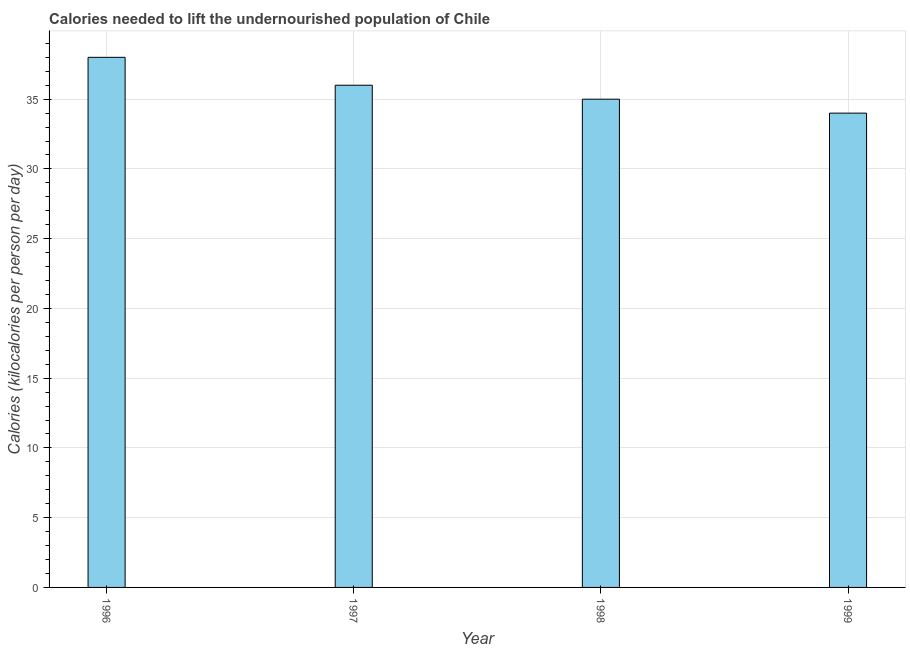Does the graph contain any zero values?
Your response must be concise. No. What is the title of the graph?
Provide a succinct answer. Calories needed to lift the undernourished population of Chile. What is the label or title of the X-axis?
Give a very brief answer. Year. What is the label or title of the Y-axis?
Give a very brief answer. Calories (kilocalories per person per day). Across all years, what is the maximum depth of food deficit?
Provide a succinct answer. 38. In which year was the depth of food deficit minimum?
Make the answer very short. 1999. What is the sum of the depth of food deficit?
Offer a terse response. 143. What is the median depth of food deficit?
Your answer should be compact. 35.5. Do a majority of the years between 1999 and 1997 (inclusive) have depth of food deficit greater than 23 kilocalories?
Provide a short and direct response. Yes. What is the ratio of the depth of food deficit in 1997 to that in 1999?
Keep it short and to the point. 1.06. What is the difference between the highest and the second highest depth of food deficit?
Make the answer very short. 2. What is the difference between the highest and the lowest depth of food deficit?
Your response must be concise. 4. In how many years, is the depth of food deficit greater than the average depth of food deficit taken over all years?
Your response must be concise. 2. Are all the bars in the graph horizontal?
Offer a very short reply. No. How many years are there in the graph?
Offer a terse response. 4. What is the difference between two consecutive major ticks on the Y-axis?
Make the answer very short. 5. What is the Calories (kilocalories per person per day) of 1999?
Keep it short and to the point. 34. What is the difference between the Calories (kilocalories per person per day) in 1996 and 1997?
Your answer should be very brief. 2. What is the difference between the Calories (kilocalories per person per day) in 1996 and 1998?
Your answer should be very brief. 3. What is the difference between the Calories (kilocalories per person per day) in 1996 and 1999?
Ensure brevity in your answer.  4. What is the difference between the Calories (kilocalories per person per day) in 1997 and 1998?
Give a very brief answer. 1. What is the difference between the Calories (kilocalories per person per day) in 1997 and 1999?
Provide a short and direct response. 2. What is the difference between the Calories (kilocalories per person per day) in 1998 and 1999?
Your answer should be very brief. 1. What is the ratio of the Calories (kilocalories per person per day) in 1996 to that in 1997?
Your response must be concise. 1.06. What is the ratio of the Calories (kilocalories per person per day) in 1996 to that in 1998?
Keep it short and to the point. 1.09. What is the ratio of the Calories (kilocalories per person per day) in 1996 to that in 1999?
Provide a succinct answer. 1.12. What is the ratio of the Calories (kilocalories per person per day) in 1997 to that in 1998?
Offer a terse response. 1.03. What is the ratio of the Calories (kilocalories per person per day) in 1997 to that in 1999?
Offer a terse response. 1.06. What is the ratio of the Calories (kilocalories per person per day) in 1998 to that in 1999?
Offer a very short reply. 1.03. 